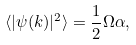<formula> <loc_0><loc_0><loc_500><loc_500>\langle | \psi ( { k } ) | ^ { 2 } \rangle = \frac { 1 } { 2 } \Omega \alpha ,</formula> 